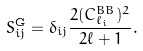<formula> <loc_0><loc_0><loc_500><loc_500>S _ { i j } ^ { \text {G} } = \delta _ { i j } \frac { 2 ( C _ { \ell _ { i } } ^ { B B } ) ^ { 2 } } { 2 \ell + 1 } .</formula> 